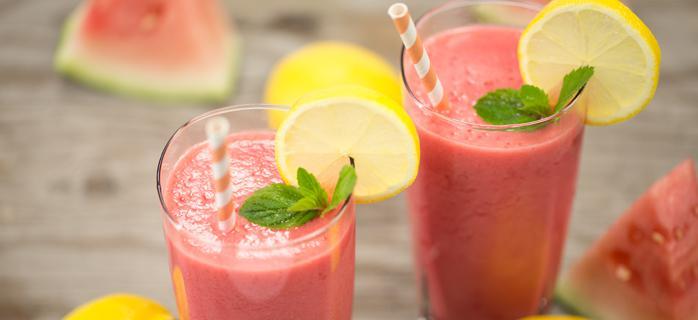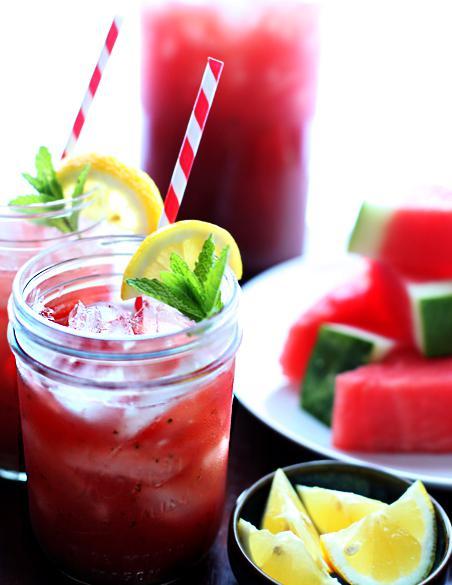The first image is the image on the left, the second image is the image on the right. Evaluate the accuracy of this statement regarding the images: "All drink servings are garnished with striped straws.". Is it true? Answer yes or no. Yes. The first image is the image on the left, the second image is the image on the right. Considering the images on both sides, is "Left image shows glasses garnished with a thin watermelon slice." valid? Answer yes or no. No. 